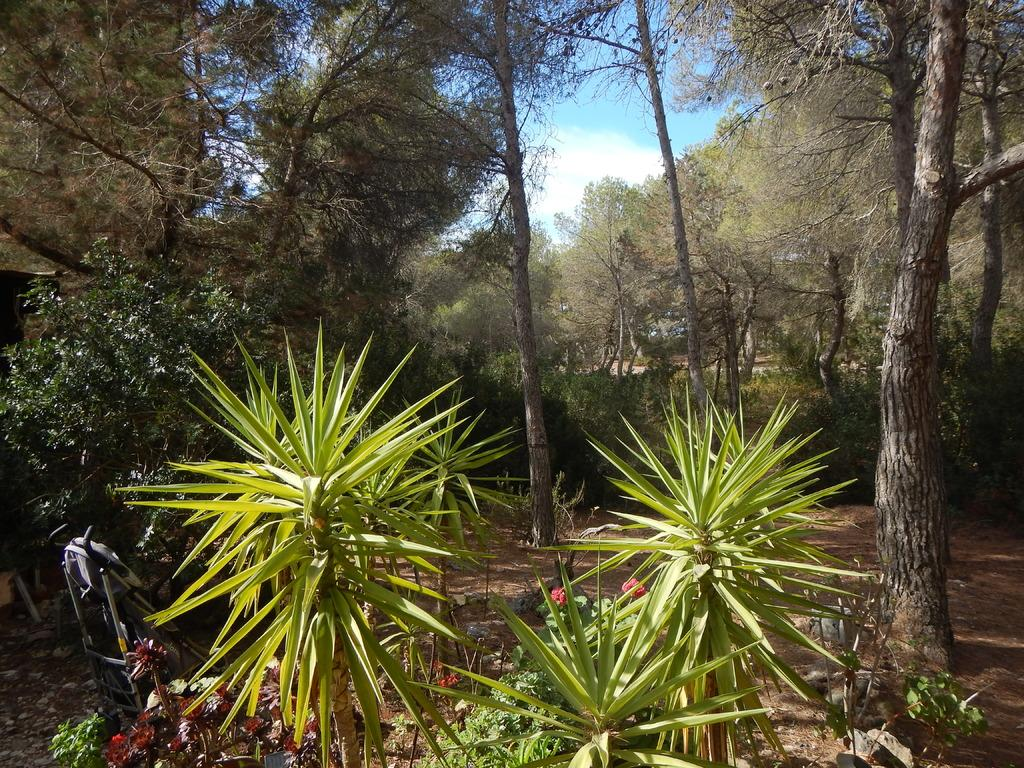What type of living organisms can be seen in the image? Plants can be seen in the image. What can be seen in the background of the image? There are trees and the sky visible in the background of the image. What type of jewel is hanging from the tree in the image? There is no jewel hanging from the tree in the image; it only features plants, trees, and the sky. 